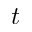<formula> <loc_0><loc_0><loc_500><loc_500>t</formula> 